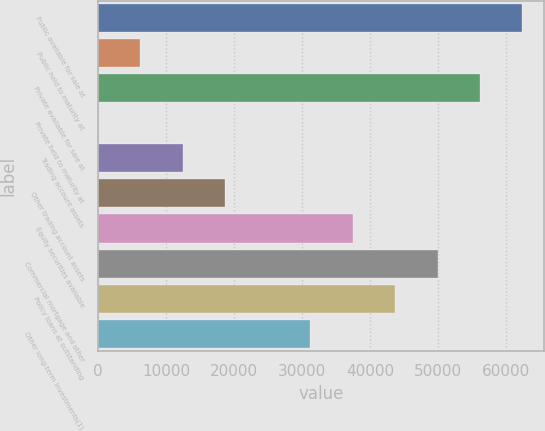Convert chart to OTSL. <chart><loc_0><loc_0><loc_500><loc_500><bar_chart><fcel>Public available for sale at<fcel>Public held to maturity at<fcel>Private available for sale at<fcel>Private held to maturity at<fcel>Trading account assets<fcel>Other trading account assets<fcel>Equity securities available<fcel>Commercial mortgage and other<fcel>Policy loans at outstanding<fcel>Other long-term investments(1)<nl><fcel>62447<fcel>6245.33<fcel>56202.4<fcel>0.7<fcel>12490<fcel>18734.6<fcel>37468.5<fcel>49957.7<fcel>43713.1<fcel>31223.8<nl></chart> 